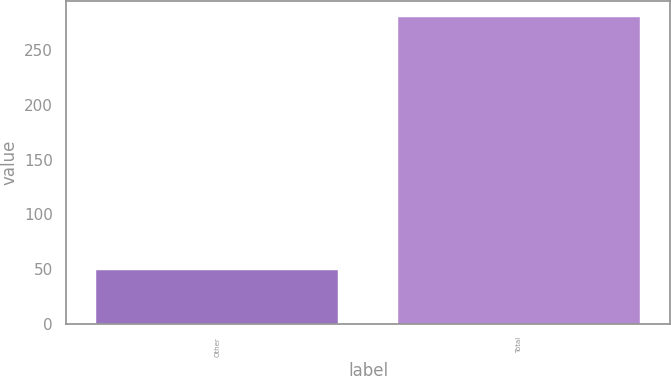<chart> <loc_0><loc_0><loc_500><loc_500><bar_chart><fcel>Other<fcel>Total<nl><fcel>49<fcel>281<nl></chart> 